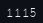<code> <loc_0><loc_0><loc_500><loc_500><_HTML_>1115</code> 